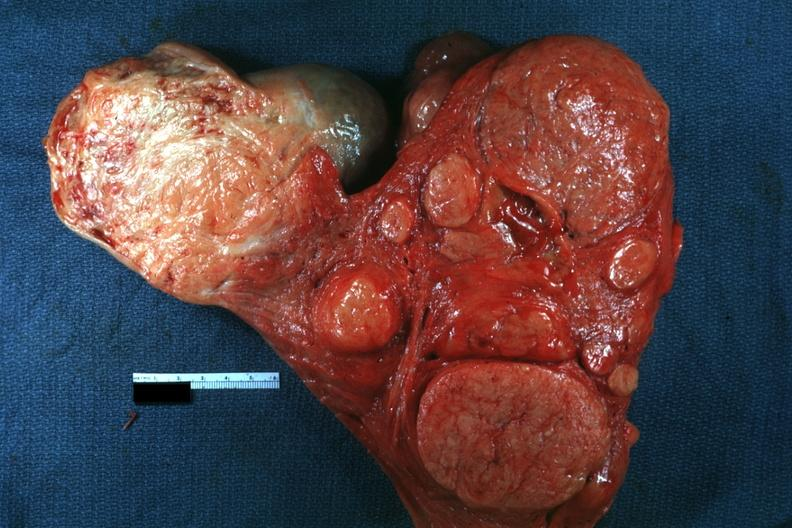s slices of liver and spleen typical tuberculous exudate is present on capsule of liver and spleen present?
Answer the question using a single word or phrase. No 